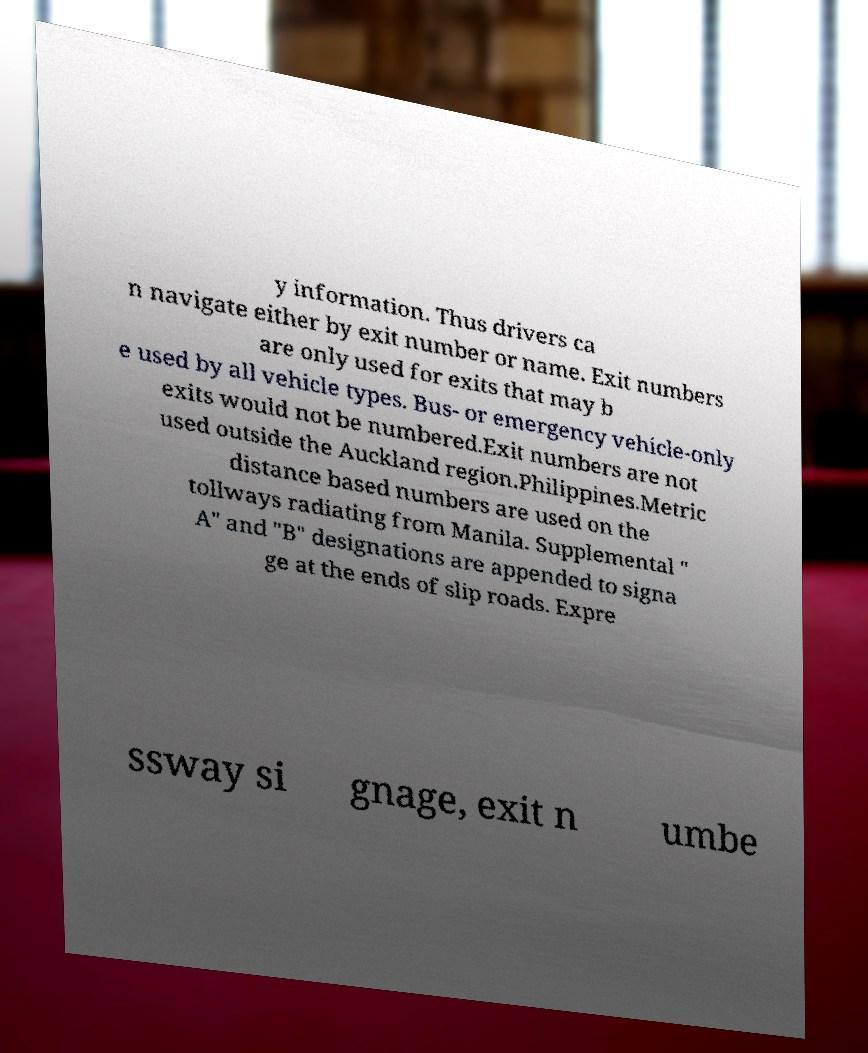Please read and relay the text visible in this image. What does it say? y information. Thus drivers ca n navigate either by exit number or name. Exit numbers are only used for exits that may b e used by all vehicle types. Bus- or emergency vehicle-only exits would not be numbered.Exit numbers are not used outside the Auckland region.Philippines.Metric distance based numbers are used on the tollways radiating from Manila. Supplemental " A" and "B" designations are appended to signa ge at the ends of slip roads. Expre ssway si gnage, exit n umbe 